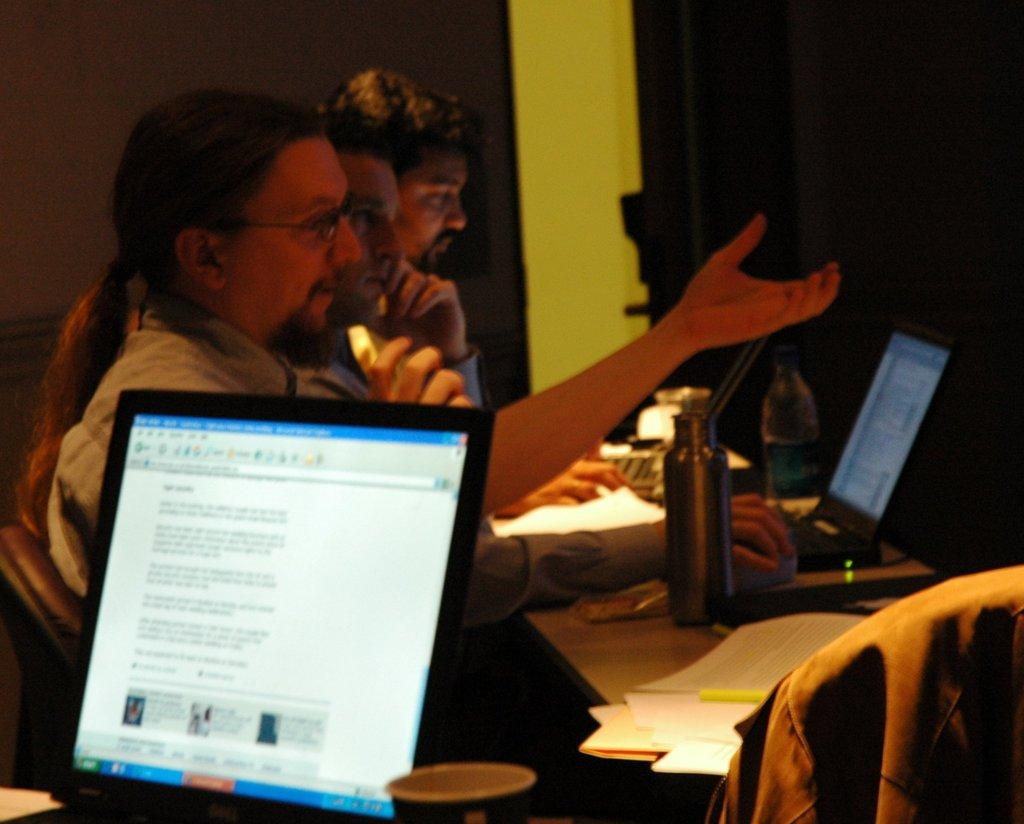How many men are in the image? There are three men in the image. What are the men doing in the image? The men are sitting in chairs. Where are the chairs located in relation to the table? The chairs are in front of a table. What items can be seen on the table? There are laptops, bottles, and papers on the table. What can be seen in the background of the image? There is a wall and a door in the background of the image. What type of zinc is present on the table in the image? There is no zinc present on the table in the image. How do the men maintain their balance while sitting in the chairs? The men do not need to maintain their balance while sitting in the chairs, as they are stationary and not in motion. 